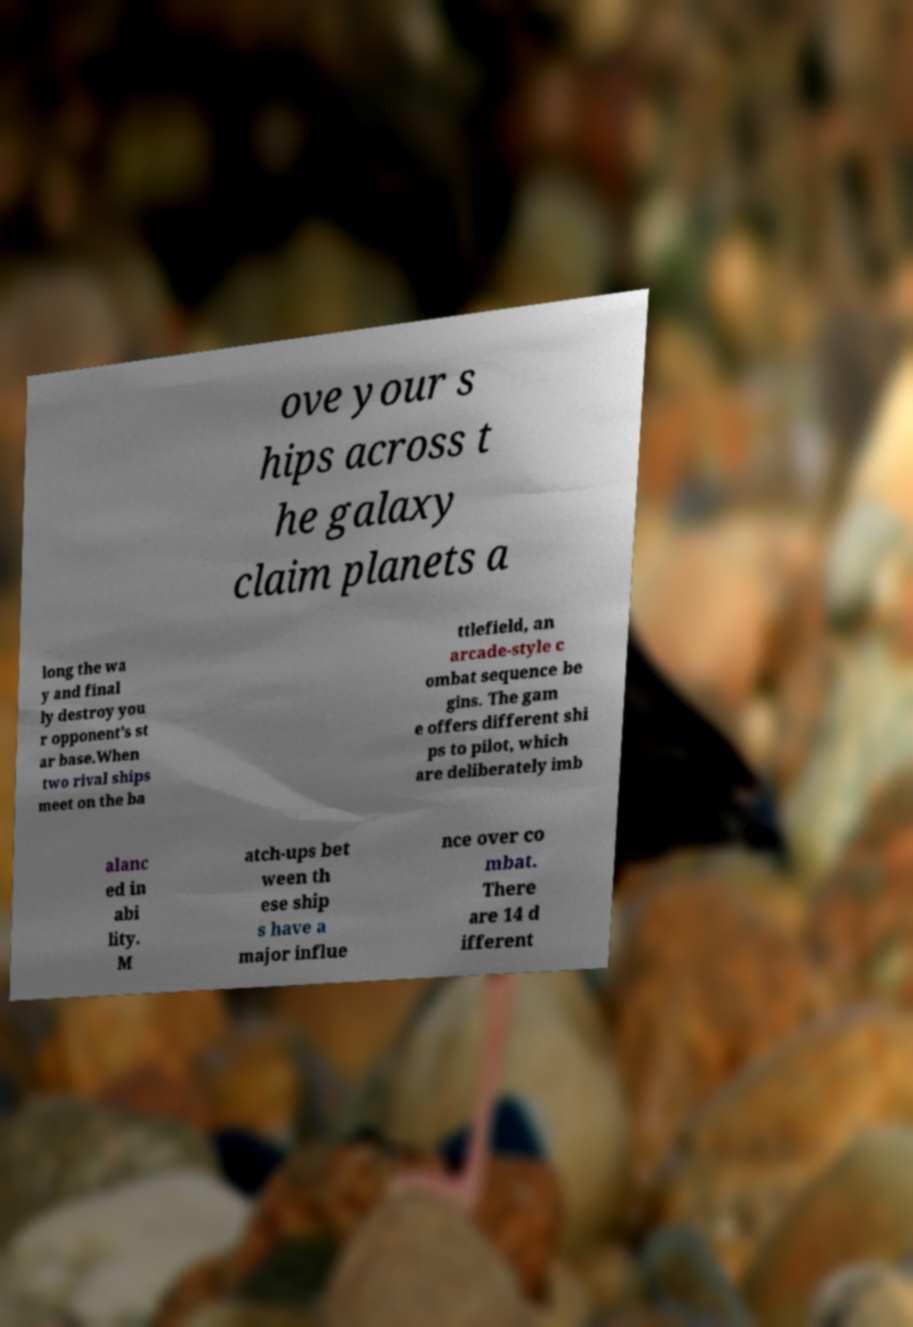What messages or text are displayed in this image? I need them in a readable, typed format. ove your s hips across t he galaxy claim planets a long the wa y and final ly destroy you r opponent’s st ar base.When two rival ships meet on the ba ttlefield, an arcade-style c ombat sequence be gins. The gam e offers different shi ps to pilot, which are deliberately imb alanc ed in abi lity. M atch-ups bet ween th ese ship s have a major influe nce over co mbat. There are 14 d ifferent 